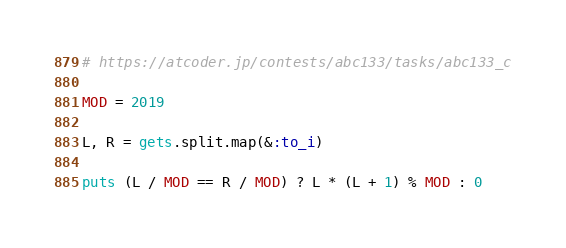<code> <loc_0><loc_0><loc_500><loc_500><_Ruby_># https://atcoder.jp/contests/abc133/tasks/abc133_c

MOD = 2019

L, R = gets.split.map(&:to_i)

puts (L / MOD == R / MOD) ? L * (L + 1) % MOD : 0
</code> 